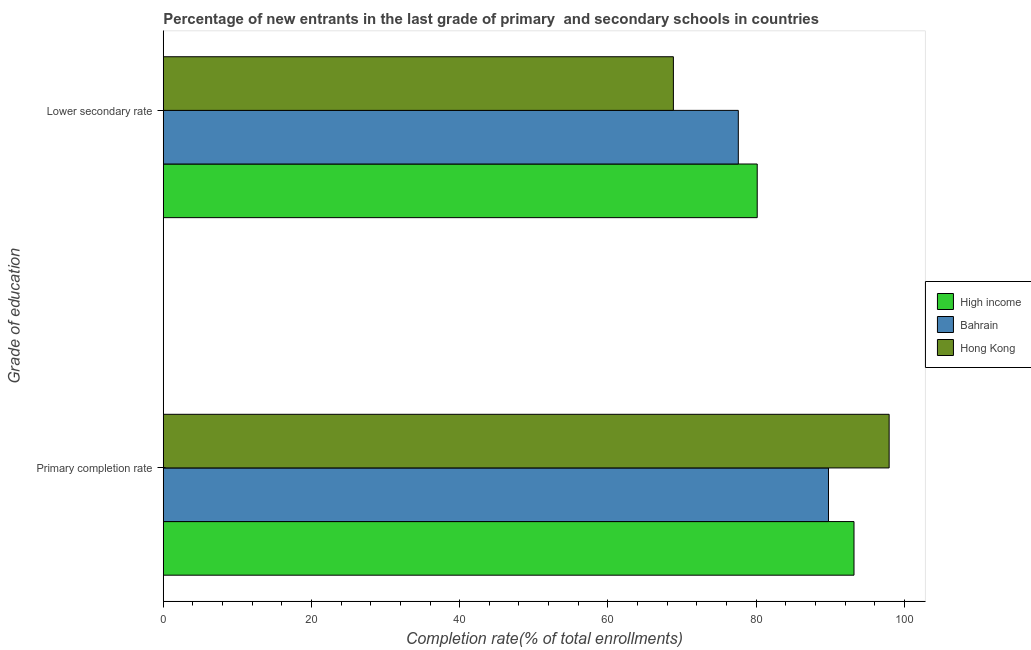How many different coloured bars are there?
Provide a short and direct response. 3. How many groups of bars are there?
Provide a succinct answer. 2. Are the number of bars per tick equal to the number of legend labels?
Make the answer very short. Yes. How many bars are there on the 2nd tick from the top?
Ensure brevity in your answer.  3. What is the label of the 2nd group of bars from the top?
Keep it short and to the point. Primary completion rate. What is the completion rate in primary schools in Bahrain?
Provide a short and direct response. 89.76. Across all countries, what is the maximum completion rate in primary schools?
Provide a short and direct response. 97.95. Across all countries, what is the minimum completion rate in primary schools?
Offer a very short reply. 89.76. In which country was the completion rate in secondary schools maximum?
Your answer should be compact. High income. In which country was the completion rate in primary schools minimum?
Ensure brevity in your answer.  Bahrain. What is the total completion rate in secondary schools in the graph?
Your answer should be very brief. 226.57. What is the difference between the completion rate in secondary schools in High income and that in Bahrain?
Offer a very short reply. 2.55. What is the difference between the completion rate in primary schools in High income and the completion rate in secondary schools in Hong Kong?
Keep it short and to the point. 24.37. What is the average completion rate in primary schools per country?
Your response must be concise. 93.64. What is the difference between the completion rate in primary schools and completion rate in secondary schools in High income?
Make the answer very short. 13.06. What is the ratio of the completion rate in primary schools in Bahrain to that in Hong Kong?
Your response must be concise. 0.92. What does the 1st bar from the top in Primary completion rate represents?
Provide a succinct answer. Hong Kong. What does the 1st bar from the bottom in Lower secondary rate represents?
Provide a succinct answer. High income. What is the difference between two consecutive major ticks on the X-axis?
Offer a very short reply. 20. Are the values on the major ticks of X-axis written in scientific E-notation?
Offer a very short reply. No. How are the legend labels stacked?
Your answer should be compact. Vertical. What is the title of the graph?
Make the answer very short. Percentage of new entrants in the last grade of primary  and secondary schools in countries. Does "Timor-Leste" appear as one of the legend labels in the graph?
Offer a terse response. No. What is the label or title of the X-axis?
Offer a very short reply. Completion rate(% of total enrollments). What is the label or title of the Y-axis?
Offer a terse response. Grade of education. What is the Completion rate(% of total enrollments) of High income in Primary completion rate?
Offer a terse response. 93.2. What is the Completion rate(% of total enrollments) in Bahrain in Primary completion rate?
Ensure brevity in your answer.  89.76. What is the Completion rate(% of total enrollments) in Hong Kong in Primary completion rate?
Your answer should be compact. 97.95. What is the Completion rate(% of total enrollments) in High income in Lower secondary rate?
Provide a short and direct response. 80.15. What is the Completion rate(% of total enrollments) of Bahrain in Lower secondary rate?
Make the answer very short. 77.59. What is the Completion rate(% of total enrollments) in Hong Kong in Lower secondary rate?
Give a very brief answer. 68.83. Across all Grade of education, what is the maximum Completion rate(% of total enrollments) in High income?
Keep it short and to the point. 93.2. Across all Grade of education, what is the maximum Completion rate(% of total enrollments) in Bahrain?
Provide a succinct answer. 89.76. Across all Grade of education, what is the maximum Completion rate(% of total enrollments) of Hong Kong?
Your answer should be compact. 97.95. Across all Grade of education, what is the minimum Completion rate(% of total enrollments) in High income?
Give a very brief answer. 80.15. Across all Grade of education, what is the minimum Completion rate(% of total enrollments) in Bahrain?
Your answer should be very brief. 77.59. Across all Grade of education, what is the minimum Completion rate(% of total enrollments) in Hong Kong?
Keep it short and to the point. 68.83. What is the total Completion rate(% of total enrollments) in High income in the graph?
Provide a succinct answer. 173.35. What is the total Completion rate(% of total enrollments) in Bahrain in the graph?
Make the answer very short. 167.36. What is the total Completion rate(% of total enrollments) in Hong Kong in the graph?
Offer a terse response. 166.78. What is the difference between the Completion rate(% of total enrollments) in High income in Primary completion rate and that in Lower secondary rate?
Your answer should be compact. 13.06. What is the difference between the Completion rate(% of total enrollments) in Bahrain in Primary completion rate and that in Lower secondary rate?
Provide a succinct answer. 12.17. What is the difference between the Completion rate(% of total enrollments) in Hong Kong in Primary completion rate and that in Lower secondary rate?
Offer a terse response. 29.11. What is the difference between the Completion rate(% of total enrollments) of High income in Primary completion rate and the Completion rate(% of total enrollments) of Bahrain in Lower secondary rate?
Offer a terse response. 15.61. What is the difference between the Completion rate(% of total enrollments) of High income in Primary completion rate and the Completion rate(% of total enrollments) of Hong Kong in Lower secondary rate?
Give a very brief answer. 24.37. What is the difference between the Completion rate(% of total enrollments) of Bahrain in Primary completion rate and the Completion rate(% of total enrollments) of Hong Kong in Lower secondary rate?
Offer a very short reply. 20.93. What is the average Completion rate(% of total enrollments) in High income per Grade of education?
Offer a very short reply. 86.67. What is the average Completion rate(% of total enrollments) of Bahrain per Grade of education?
Make the answer very short. 83.68. What is the average Completion rate(% of total enrollments) in Hong Kong per Grade of education?
Give a very brief answer. 83.39. What is the difference between the Completion rate(% of total enrollments) of High income and Completion rate(% of total enrollments) of Bahrain in Primary completion rate?
Make the answer very short. 3.44. What is the difference between the Completion rate(% of total enrollments) in High income and Completion rate(% of total enrollments) in Hong Kong in Primary completion rate?
Keep it short and to the point. -4.74. What is the difference between the Completion rate(% of total enrollments) in Bahrain and Completion rate(% of total enrollments) in Hong Kong in Primary completion rate?
Provide a short and direct response. -8.18. What is the difference between the Completion rate(% of total enrollments) in High income and Completion rate(% of total enrollments) in Bahrain in Lower secondary rate?
Provide a succinct answer. 2.55. What is the difference between the Completion rate(% of total enrollments) of High income and Completion rate(% of total enrollments) of Hong Kong in Lower secondary rate?
Offer a very short reply. 11.31. What is the difference between the Completion rate(% of total enrollments) of Bahrain and Completion rate(% of total enrollments) of Hong Kong in Lower secondary rate?
Offer a terse response. 8.76. What is the ratio of the Completion rate(% of total enrollments) of High income in Primary completion rate to that in Lower secondary rate?
Keep it short and to the point. 1.16. What is the ratio of the Completion rate(% of total enrollments) in Bahrain in Primary completion rate to that in Lower secondary rate?
Your answer should be very brief. 1.16. What is the ratio of the Completion rate(% of total enrollments) in Hong Kong in Primary completion rate to that in Lower secondary rate?
Your answer should be very brief. 1.42. What is the difference between the highest and the second highest Completion rate(% of total enrollments) in High income?
Your answer should be very brief. 13.06. What is the difference between the highest and the second highest Completion rate(% of total enrollments) in Bahrain?
Give a very brief answer. 12.17. What is the difference between the highest and the second highest Completion rate(% of total enrollments) of Hong Kong?
Offer a terse response. 29.11. What is the difference between the highest and the lowest Completion rate(% of total enrollments) of High income?
Offer a terse response. 13.06. What is the difference between the highest and the lowest Completion rate(% of total enrollments) of Bahrain?
Make the answer very short. 12.17. What is the difference between the highest and the lowest Completion rate(% of total enrollments) in Hong Kong?
Provide a short and direct response. 29.11. 